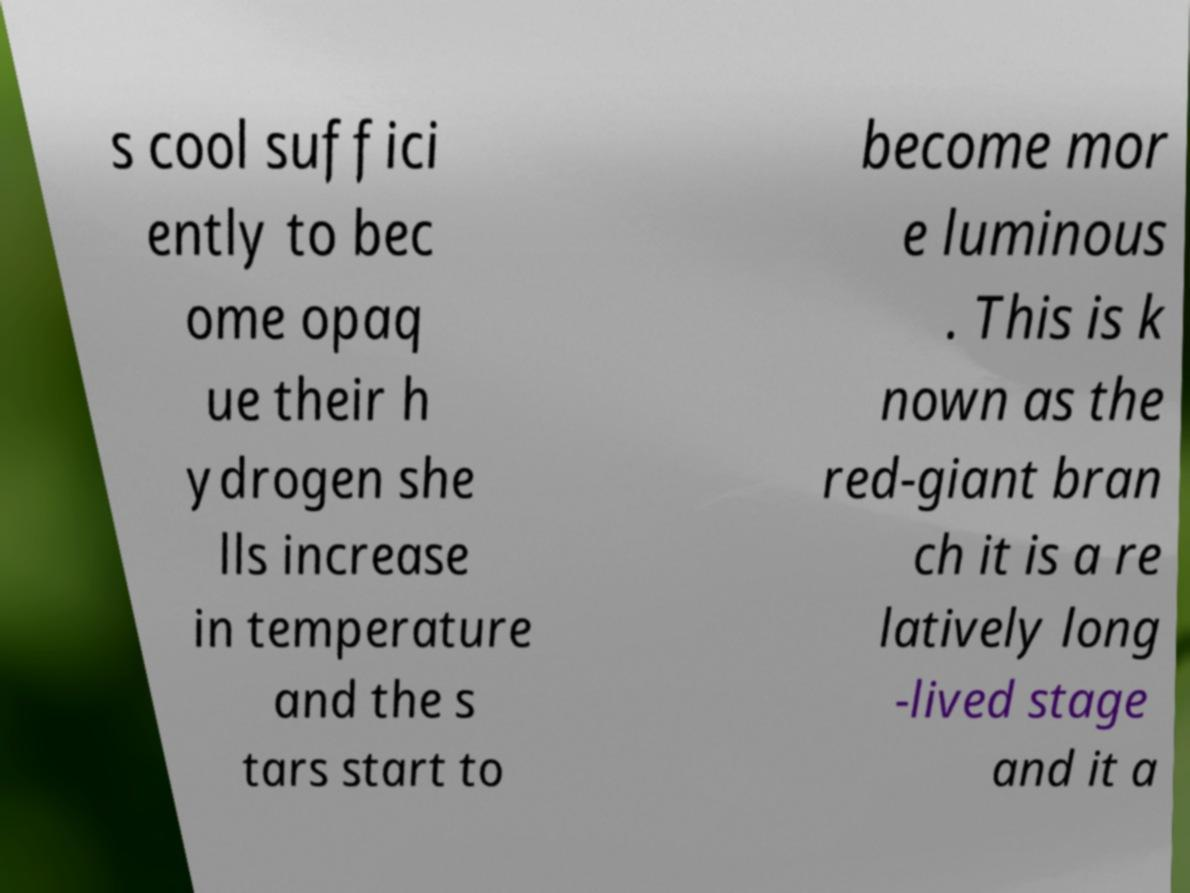Could you assist in decoding the text presented in this image and type it out clearly? s cool suffici ently to bec ome opaq ue their h ydrogen she lls increase in temperature and the s tars start to become mor e luminous . This is k nown as the red-giant bran ch it is a re latively long -lived stage and it a 